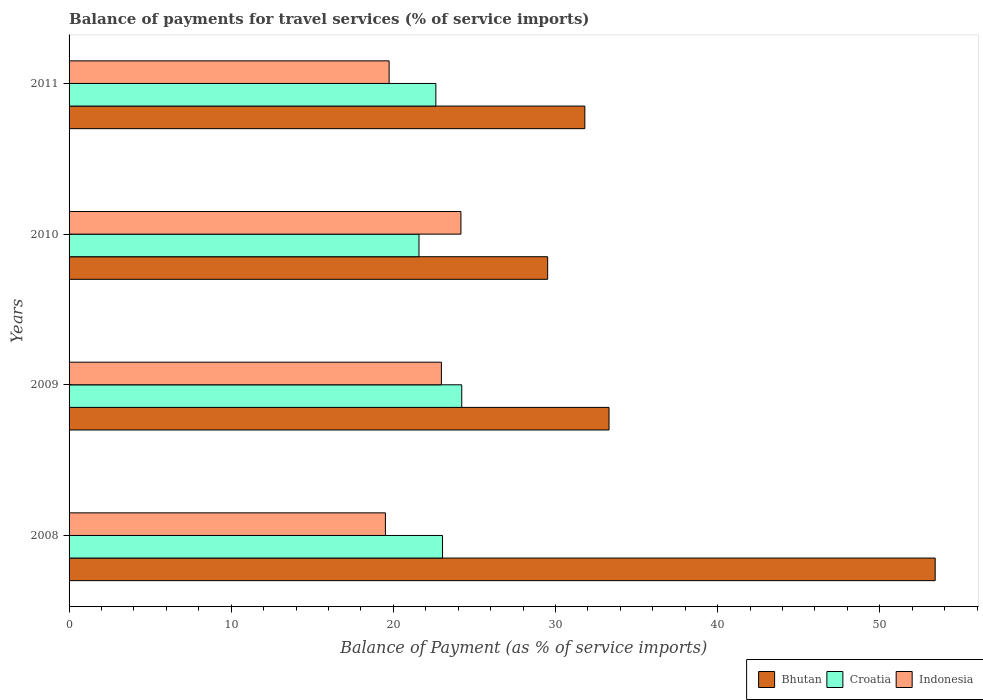How many different coloured bars are there?
Provide a short and direct response. 3. Are the number of bars per tick equal to the number of legend labels?
Offer a terse response. Yes. Are the number of bars on each tick of the Y-axis equal?
Provide a short and direct response. Yes. How many bars are there on the 4th tick from the top?
Your answer should be compact. 3. How many bars are there on the 2nd tick from the bottom?
Offer a very short reply. 3. In how many cases, is the number of bars for a given year not equal to the number of legend labels?
Ensure brevity in your answer.  0. What is the balance of payments for travel services in Bhutan in 2010?
Your response must be concise. 29.52. Across all years, what is the maximum balance of payments for travel services in Indonesia?
Your response must be concise. 24.17. Across all years, what is the minimum balance of payments for travel services in Bhutan?
Offer a terse response. 29.52. In which year was the balance of payments for travel services in Indonesia maximum?
Your response must be concise. 2010. In which year was the balance of payments for travel services in Croatia minimum?
Give a very brief answer. 2010. What is the total balance of payments for travel services in Croatia in the graph?
Your response must be concise. 91.45. What is the difference between the balance of payments for travel services in Croatia in 2009 and that in 2010?
Your response must be concise. 2.64. What is the difference between the balance of payments for travel services in Croatia in 2011 and the balance of payments for travel services in Bhutan in 2008?
Offer a terse response. -30.79. What is the average balance of payments for travel services in Croatia per year?
Ensure brevity in your answer.  22.86. In the year 2011, what is the difference between the balance of payments for travel services in Indonesia and balance of payments for travel services in Croatia?
Your answer should be very brief. -2.88. In how many years, is the balance of payments for travel services in Bhutan greater than 44 %?
Give a very brief answer. 1. What is the ratio of the balance of payments for travel services in Indonesia in 2008 to that in 2009?
Keep it short and to the point. 0.85. What is the difference between the highest and the second highest balance of payments for travel services in Croatia?
Make the answer very short. 1.19. What is the difference between the highest and the lowest balance of payments for travel services in Croatia?
Provide a succinct answer. 2.64. What does the 1st bar from the top in 2010 represents?
Keep it short and to the point. Indonesia. What does the 1st bar from the bottom in 2011 represents?
Your answer should be very brief. Bhutan. Is it the case that in every year, the sum of the balance of payments for travel services in Bhutan and balance of payments for travel services in Indonesia is greater than the balance of payments for travel services in Croatia?
Ensure brevity in your answer.  Yes. How many years are there in the graph?
Your answer should be compact. 4. Are the values on the major ticks of X-axis written in scientific E-notation?
Keep it short and to the point. No. Does the graph contain any zero values?
Your response must be concise. No. Does the graph contain grids?
Provide a succinct answer. No. Where does the legend appear in the graph?
Provide a short and direct response. Bottom right. How many legend labels are there?
Offer a very short reply. 3. What is the title of the graph?
Make the answer very short. Balance of payments for travel services (% of service imports). What is the label or title of the X-axis?
Offer a terse response. Balance of Payment (as % of service imports). What is the Balance of Payment (as % of service imports) in Bhutan in 2008?
Make the answer very short. 53.42. What is the Balance of Payment (as % of service imports) in Croatia in 2008?
Your answer should be very brief. 23.03. What is the Balance of Payment (as % of service imports) in Indonesia in 2008?
Offer a very short reply. 19.51. What is the Balance of Payment (as % of service imports) in Bhutan in 2009?
Offer a very short reply. 33.3. What is the Balance of Payment (as % of service imports) in Croatia in 2009?
Offer a very short reply. 24.22. What is the Balance of Payment (as % of service imports) of Indonesia in 2009?
Your answer should be compact. 22.96. What is the Balance of Payment (as % of service imports) of Bhutan in 2010?
Your answer should be compact. 29.52. What is the Balance of Payment (as % of service imports) of Croatia in 2010?
Offer a terse response. 21.58. What is the Balance of Payment (as % of service imports) in Indonesia in 2010?
Keep it short and to the point. 24.17. What is the Balance of Payment (as % of service imports) of Bhutan in 2011?
Make the answer very short. 31.81. What is the Balance of Payment (as % of service imports) in Croatia in 2011?
Your answer should be compact. 22.62. What is the Balance of Payment (as % of service imports) of Indonesia in 2011?
Provide a short and direct response. 19.74. Across all years, what is the maximum Balance of Payment (as % of service imports) of Bhutan?
Provide a short and direct response. 53.42. Across all years, what is the maximum Balance of Payment (as % of service imports) in Croatia?
Keep it short and to the point. 24.22. Across all years, what is the maximum Balance of Payment (as % of service imports) in Indonesia?
Offer a very short reply. 24.17. Across all years, what is the minimum Balance of Payment (as % of service imports) in Bhutan?
Your answer should be compact. 29.52. Across all years, what is the minimum Balance of Payment (as % of service imports) in Croatia?
Offer a terse response. 21.58. Across all years, what is the minimum Balance of Payment (as % of service imports) in Indonesia?
Ensure brevity in your answer.  19.51. What is the total Balance of Payment (as % of service imports) in Bhutan in the graph?
Your answer should be compact. 148.04. What is the total Balance of Payment (as % of service imports) of Croatia in the graph?
Keep it short and to the point. 91.45. What is the total Balance of Payment (as % of service imports) in Indonesia in the graph?
Provide a short and direct response. 86.37. What is the difference between the Balance of Payment (as % of service imports) of Bhutan in 2008 and that in 2009?
Keep it short and to the point. 20.11. What is the difference between the Balance of Payment (as % of service imports) in Croatia in 2008 and that in 2009?
Give a very brief answer. -1.19. What is the difference between the Balance of Payment (as % of service imports) in Indonesia in 2008 and that in 2009?
Keep it short and to the point. -3.45. What is the difference between the Balance of Payment (as % of service imports) in Bhutan in 2008 and that in 2010?
Keep it short and to the point. 23.9. What is the difference between the Balance of Payment (as % of service imports) in Croatia in 2008 and that in 2010?
Provide a succinct answer. 1.45. What is the difference between the Balance of Payment (as % of service imports) of Indonesia in 2008 and that in 2010?
Your response must be concise. -4.66. What is the difference between the Balance of Payment (as % of service imports) of Bhutan in 2008 and that in 2011?
Make the answer very short. 21.61. What is the difference between the Balance of Payment (as % of service imports) in Croatia in 2008 and that in 2011?
Provide a succinct answer. 0.41. What is the difference between the Balance of Payment (as % of service imports) in Indonesia in 2008 and that in 2011?
Keep it short and to the point. -0.23. What is the difference between the Balance of Payment (as % of service imports) of Bhutan in 2009 and that in 2010?
Provide a short and direct response. 3.78. What is the difference between the Balance of Payment (as % of service imports) of Croatia in 2009 and that in 2010?
Ensure brevity in your answer.  2.64. What is the difference between the Balance of Payment (as % of service imports) of Indonesia in 2009 and that in 2010?
Make the answer very short. -1.2. What is the difference between the Balance of Payment (as % of service imports) of Bhutan in 2009 and that in 2011?
Keep it short and to the point. 1.49. What is the difference between the Balance of Payment (as % of service imports) in Croatia in 2009 and that in 2011?
Give a very brief answer. 1.6. What is the difference between the Balance of Payment (as % of service imports) in Indonesia in 2009 and that in 2011?
Make the answer very short. 3.22. What is the difference between the Balance of Payment (as % of service imports) of Bhutan in 2010 and that in 2011?
Your answer should be very brief. -2.29. What is the difference between the Balance of Payment (as % of service imports) in Croatia in 2010 and that in 2011?
Ensure brevity in your answer.  -1.04. What is the difference between the Balance of Payment (as % of service imports) in Indonesia in 2010 and that in 2011?
Your answer should be compact. 4.43. What is the difference between the Balance of Payment (as % of service imports) in Bhutan in 2008 and the Balance of Payment (as % of service imports) in Croatia in 2009?
Offer a very short reply. 29.2. What is the difference between the Balance of Payment (as % of service imports) of Bhutan in 2008 and the Balance of Payment (as % of service imports) of Indonesia in 2009?
Provide a short and direct response. 30.45. What is the difference between the Balance of Payment (as % of service imports) of Croatia in 2008 and the Balance of Payment (as % of service imports) of Indonesia in 2009?
Your answer should be very brief. 0.07. What is the difference between the Balance of Payment (as % of service imports) in Bhutan in 2008 and the Balance of Payment (as % of service imports) in Croatia in 2010?
Your answer should be very brief. 31.83. What is the difference between the Balance of Payment (as % of service imports) in Bhutan in 2008 and the Balance of Payment (as % of service imports) in Indonesia in 2010?
Provide a short and direct response. 29.25. What is the difference between the Balance of Payment (as % of service imports) in Croatia in 2008 and the Balance of Payment (as % of service imports) in Indonesia in 2010?
Offer a very short reply. -1.13. What is the difference between the Balance of Payment (as % of service imports) of Bhutan in 2008 and the Balance of Payment (as % of service imports) of Croatia in 2011?
Your response must be concise. 30.79. What is the difference between the Balance of Payment (as % of service imports) of Bhutan in 2008 and the Balance of Payment (as % of service imports) of Indonesia in 2011?
Offer a very short reply. 33.68. What is the difference between the Balance of Payment (as % of service imports) in Croatia in 2008 and the Balance of Payment (as % of service imports) in Indonesia in 2011?
Offer a terse response. 3.29. What is the difference between the Balance of Payment (as % of service imports) of Bhutan in 2009 and the Balance of Payment (as % of service imports) of Croatia in 2010?
Your answer should be very brief. 11.72. What is the difference between the Balance of Payment (as % of service imports) in Bhutan in 2009 and the Balance of Payment (as % of service imports) in Indonesia in 2010?
Provide a succinct answer. 9.13. What is the difference between the Balance of Payment (as % of service imports) in Croatia in 2009 and the Balance of Payment (as % of service imports) in Indonesia in 2010?
Your answer should be compact. 0.05. What is the difference between the Balance of Payment (as % of service imports) in Bhutan in 2009 and the Balance of Payment (as % of service imports) in Croatia in 2011?
Your answer should be very brief. 10.68. What is the difference between the Balance of Payment (as % of service imports) of Bhutan in 2009 and the Balance of Payment (as % of service imports) of Indonesia in 2011?
Make the answer very short. 13.56. What is the difference between the Balance of Payment (as % of service imports) of Croatia in 2009 and the Balance of Payment (as % of service imports) of Indonesia in 2011?
Make the answer very short. 4.48. What is the difference between the Balance of Payment (as % of service imports) in Bhutan in 2010 and the Balance of Payment (as % of service imports) in Croatia in 2011?
Your answer should be compact. 6.89. What is the difference between the Balance of Payment (as % of service imports) in Bhutan in 2010 and the Balance of Payment (as % of service imports) in Indonesia in 2011?
Give a very brief answer. 9.78. What is the difference between the Balance of Payment (as % of service imports) in Croatia in 2010 and the Balance of Payment (as % of service imports) in Indonesia in 2011?
Provide a short and direct response. 1.84. What is the average Balance of Payment (as % of service imports) of Bhutan per year?
Offer a terse response. 37.01. What is the average Balance of Payment (as % of service imports) of Croatia per year?
Make the answer very short. 22.86. What is the average Balance of Payment (as % of service imports) of Indonesia per year?
Your answer should be compact. 21.59. In the year 2008, what is the difference between the Balance of Payment (as % of service imports) of Bhutan and Balance of Payment (as % of service imports) of Croatia?
Keep it short and to the point. 30.38. In the year 2008, what is the difference between the Balance of Payment (as % of service imports) in Bhutan and Balance of Payment (as % of service imports) in Indonesia?
Keep it short and to the point. 33.91. In the year 2008, what is the difference between the Balance of Payment (as % of service imports) in Croatia and Balance of Payment (as % of service imports) in Indonesia?
Offer a terse response. 3.52. In the year 2009, what is the difference between the Balance of Payment (as % of service imports) in Bhutan and Balance of Payment (as % of service imports) in Croatia?
Your response must be concise. 9.08. In the year 2009, what is the difference between the Balance of Payment (as % of service imports) of Bhutan and Balance of Payment (as % of service imports) of Indonesia?
Your answer should be compact. 10.34. In the year 2009, what is the difference between the Balance of Payment (as % of service imports) of Croatia and Balance of Payment (as % of service imports) of Indonesia?
Keep it short and to the point. 1.26. In the year 2010, what is the difference between the Balance of Payment (as % of service imports) in Bhutan and Balance of Payment (as % of service imports) in Croatia?
Ensure brevity in your answer.  7.94. In the year 2010, what is the difference between the Balance of Payment (as % of service imports) of Bhutan and Balance of Payment (as % of service imports) of Indonesia?
Your response must be concise. 5.35. In the year 2010, what is the difference between the Balance of Payment (as % of service imports) of Croatia and Balance of Payment (as % of service imports) of Indonesia?
Offer a terse response. -2.59. In the year 2011, what is the difference between the Balance of Payment (as % of service imports) in Bhutan and Balance of Payment (as % of service imports) in Croatia?
Offer a terse response. 9.19. In the year 2011, what is the difference between the Balance of Payment (as % of service imports) in Bhutan and Balance of Payment (as % of service imports) in Indonesia?
Make the answer very short. 12.07. In the year 2011, what is the difference between the Balance of Payment (as % of service imports) of Croatia and Balance of Payment (as % of service imports) of Indonesia?
Offer a very short reply. 2.88. What is the ratio of the Balance of Payment (as % of service imports) in Bhutan in 2008 to that in 2009?
Your answer should be very brief. 1.6. What is the ratio of the Balance of Payment (as % of service imports) in Croatia in 2008 to that in 2009?
Give a very brief answer. 0.95. What is the ratio of the Balance of Payment (as % of service imports) in Indonesia in 2008 to that in 2009?
Offer a very short reply. 0.85. What is the ratio of the Balance of Payment (as % of service imports) in Bhutan in 2008 to that in 2010?
Provide a short and direct response. 1.81. What is the ratio of the Balance of Payment (as % of service imports) in Croatia in 2008 to that in 2010?
Give a very brief answer. 1.07. What is the ratio of the Balance of Payment (as % of service imports) in Indonesia in 2008 to that in 2010?
Provide a succinct answer. 0.81. What is the ratio of the Balance of Payment (as % of service imports) of Bhutan in 2008 to that in 2011?
Ensure brevity in your answer.  1.68. What is the ratio of the Balance of Payment (as % of service imports) in Croatia in 2008 to that in 2011?
Your answer should be compact. 1.02. What is the ratio of the Balance of Payment (as % of service imports) of Indonesia in 2008 to that in 2011?
Offer a terse response. 0.99. What is the ratio of the Balance of Payment (as % of service imports) of Bhutan in 2009 to that in 2010?
Keep it short and to the point. 1.13. What is the ratio of the Balance of Payment (as % of service imports) in Croatia in 2009 to that in 2010?
Give a very brief answer. 1.12. What is the ratio of the Balance of Payment (as % of service imports) of Indonesia in 2009 to that in 2010?
Ensure brevity in your answer.  0.95. What is the ratio of the Balance of Payment (as % of service imports) in Bhutan in 2009 to that in 2011?
Offer a very short reply. 1.05. What is the ratio of the Balance of Payment (as % of service imports) in Croatia in 2009 to that in 2011?
Make the answer very short. 1.07. What is the ratio of the Balance of Payment (as % of service imports) of Indonesia in 2009 to that in 2011?
Offer a terse response. 1.16. What is the ratio of the Balance of Payment (as % of service imports) of Bhutan in 2010 to that in 2011?
Your response must be concise. 0.93. What is the ratio of the Balance of Payment (as % of service imports) in Croatia in 2010 to that in 2011?
Make the answer very short. 0.95. What is the ratio of the Balance of Payment (as % of service imports) of Indonesia in 2010 to that in 2011?
Provide a succinct answer. 1.22. What is the difference between the highest and the second highest Balance of Payment (as % of service imports) in Bhutan?
Keep it short and to the point. 20.11. What is the difference between the highest and the second highest Balance of Payment (as % of service imports) in Croatia?
Make the answer very short. 1.19. What is the difference between the highest and the second highest Balance of Payment (as % of service imports) of Indonesia?
Make the answer very short. 1.2. What is the difference between the highest and the lowest Balance of Payment (as % of service imports) in Bhutan?
Provide a short and direct response. 23.9. What is the difference between the highest and the lowest Balance of Payment (as % of service imports) in Croatia?
Ensure brevity in your answer.  2.64. What is the difference between the highest and the lowest Balance of Payment (as % of service imports) of Indonesia?
Give a very brief answer. 4.66. 